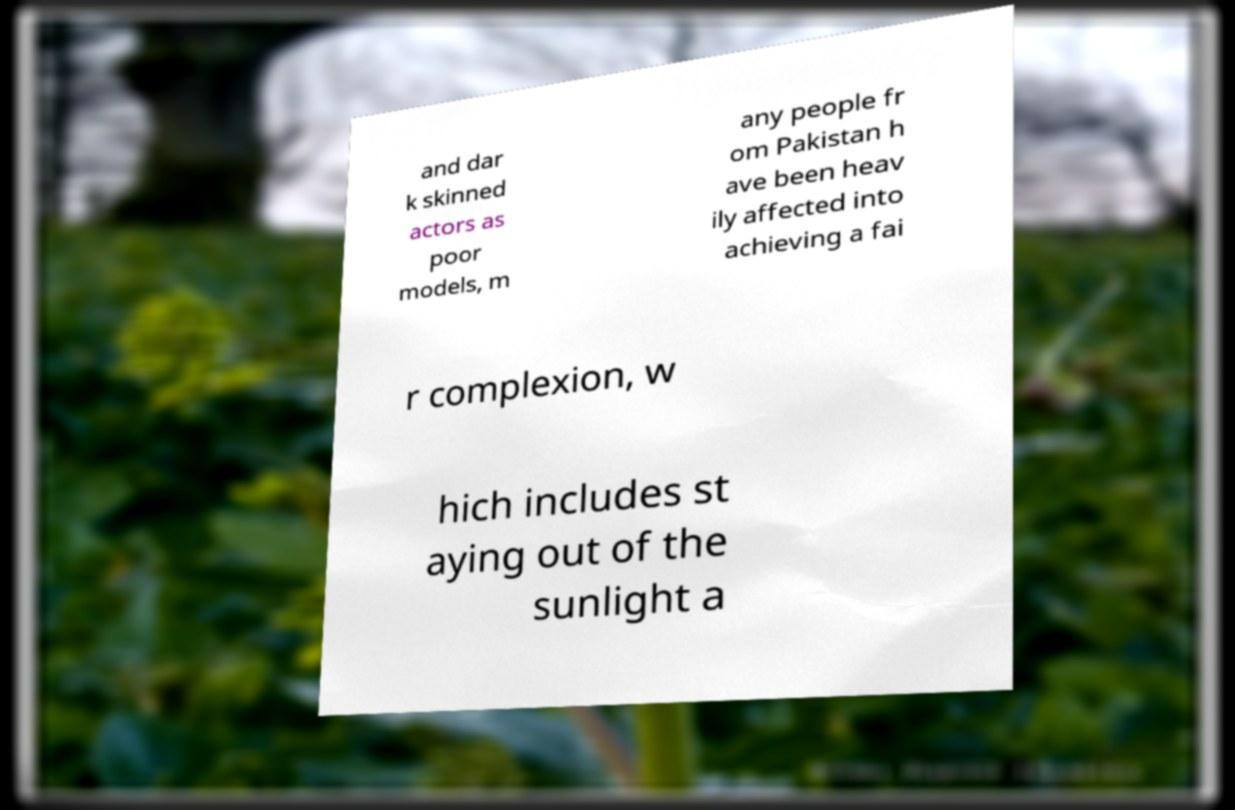Can you accurately transcribe the text from the provided image for me? and dar k skinned actors as poor models, m any people fr om Pakistan h ave been heav ily affected into achieving a fai r complexion, w hich includes st aying out of the sunlight a 